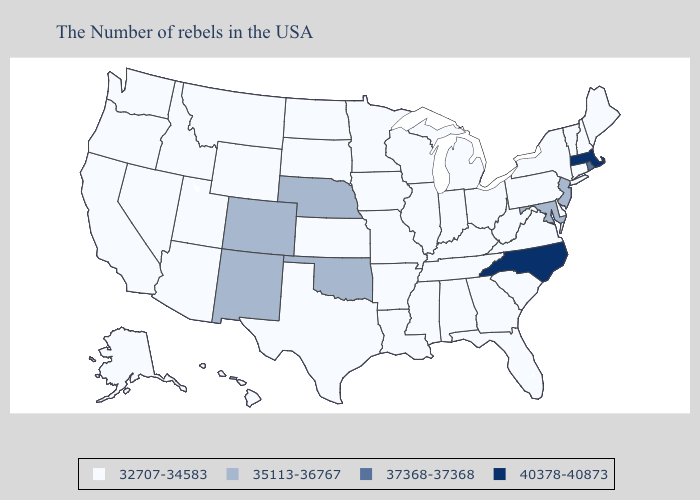What is the value of Nevada?
Answer briefly. 32707-34583. What is the highest value in states that border Montana?
Short answer required. 32707-34583. Does Tennessee have the highest value in the USA?
Concise answer only. No. What is the highest value in states that border Kansas?
Quick response, please. 35113-36767. Does New Hampshire have the highest value in the Northeast?
Quick response, please. No. How many symbols are there in the legend?
Quick response, please. 4. Among the states that border South Dakota , which have the highest value?
Quick response, please. Nebraska. What is the value of Oklahoma?
Quick response, please. 35113-36767. Among the states that border North Carolina , which have the highest value?
Give a very brief answer. Virginia, South Carolina, Georgia, Tennessee. Name the states that have a value in the range 37368-37368?
Short answer required. Rhode Island. Name the states that have a value in the range 35113-36767?
Short answer required. New Jersey, Maryland, Nebraska, Oklahoma, Colorado, New Mexico. Does Minnesota have the same value as Pennsylvania?
Keep it brief. Yes. Is the legend a continuous bar?
Keep it brief. No. What is the value of Arizona?
Answer briefly. 32707-34583. Name the states that have a value in the range 35113-36767?
Give a very brief answer. New Jersey, Maryland, Nebraska, Oklahoma, Colorado, New Mexico. 